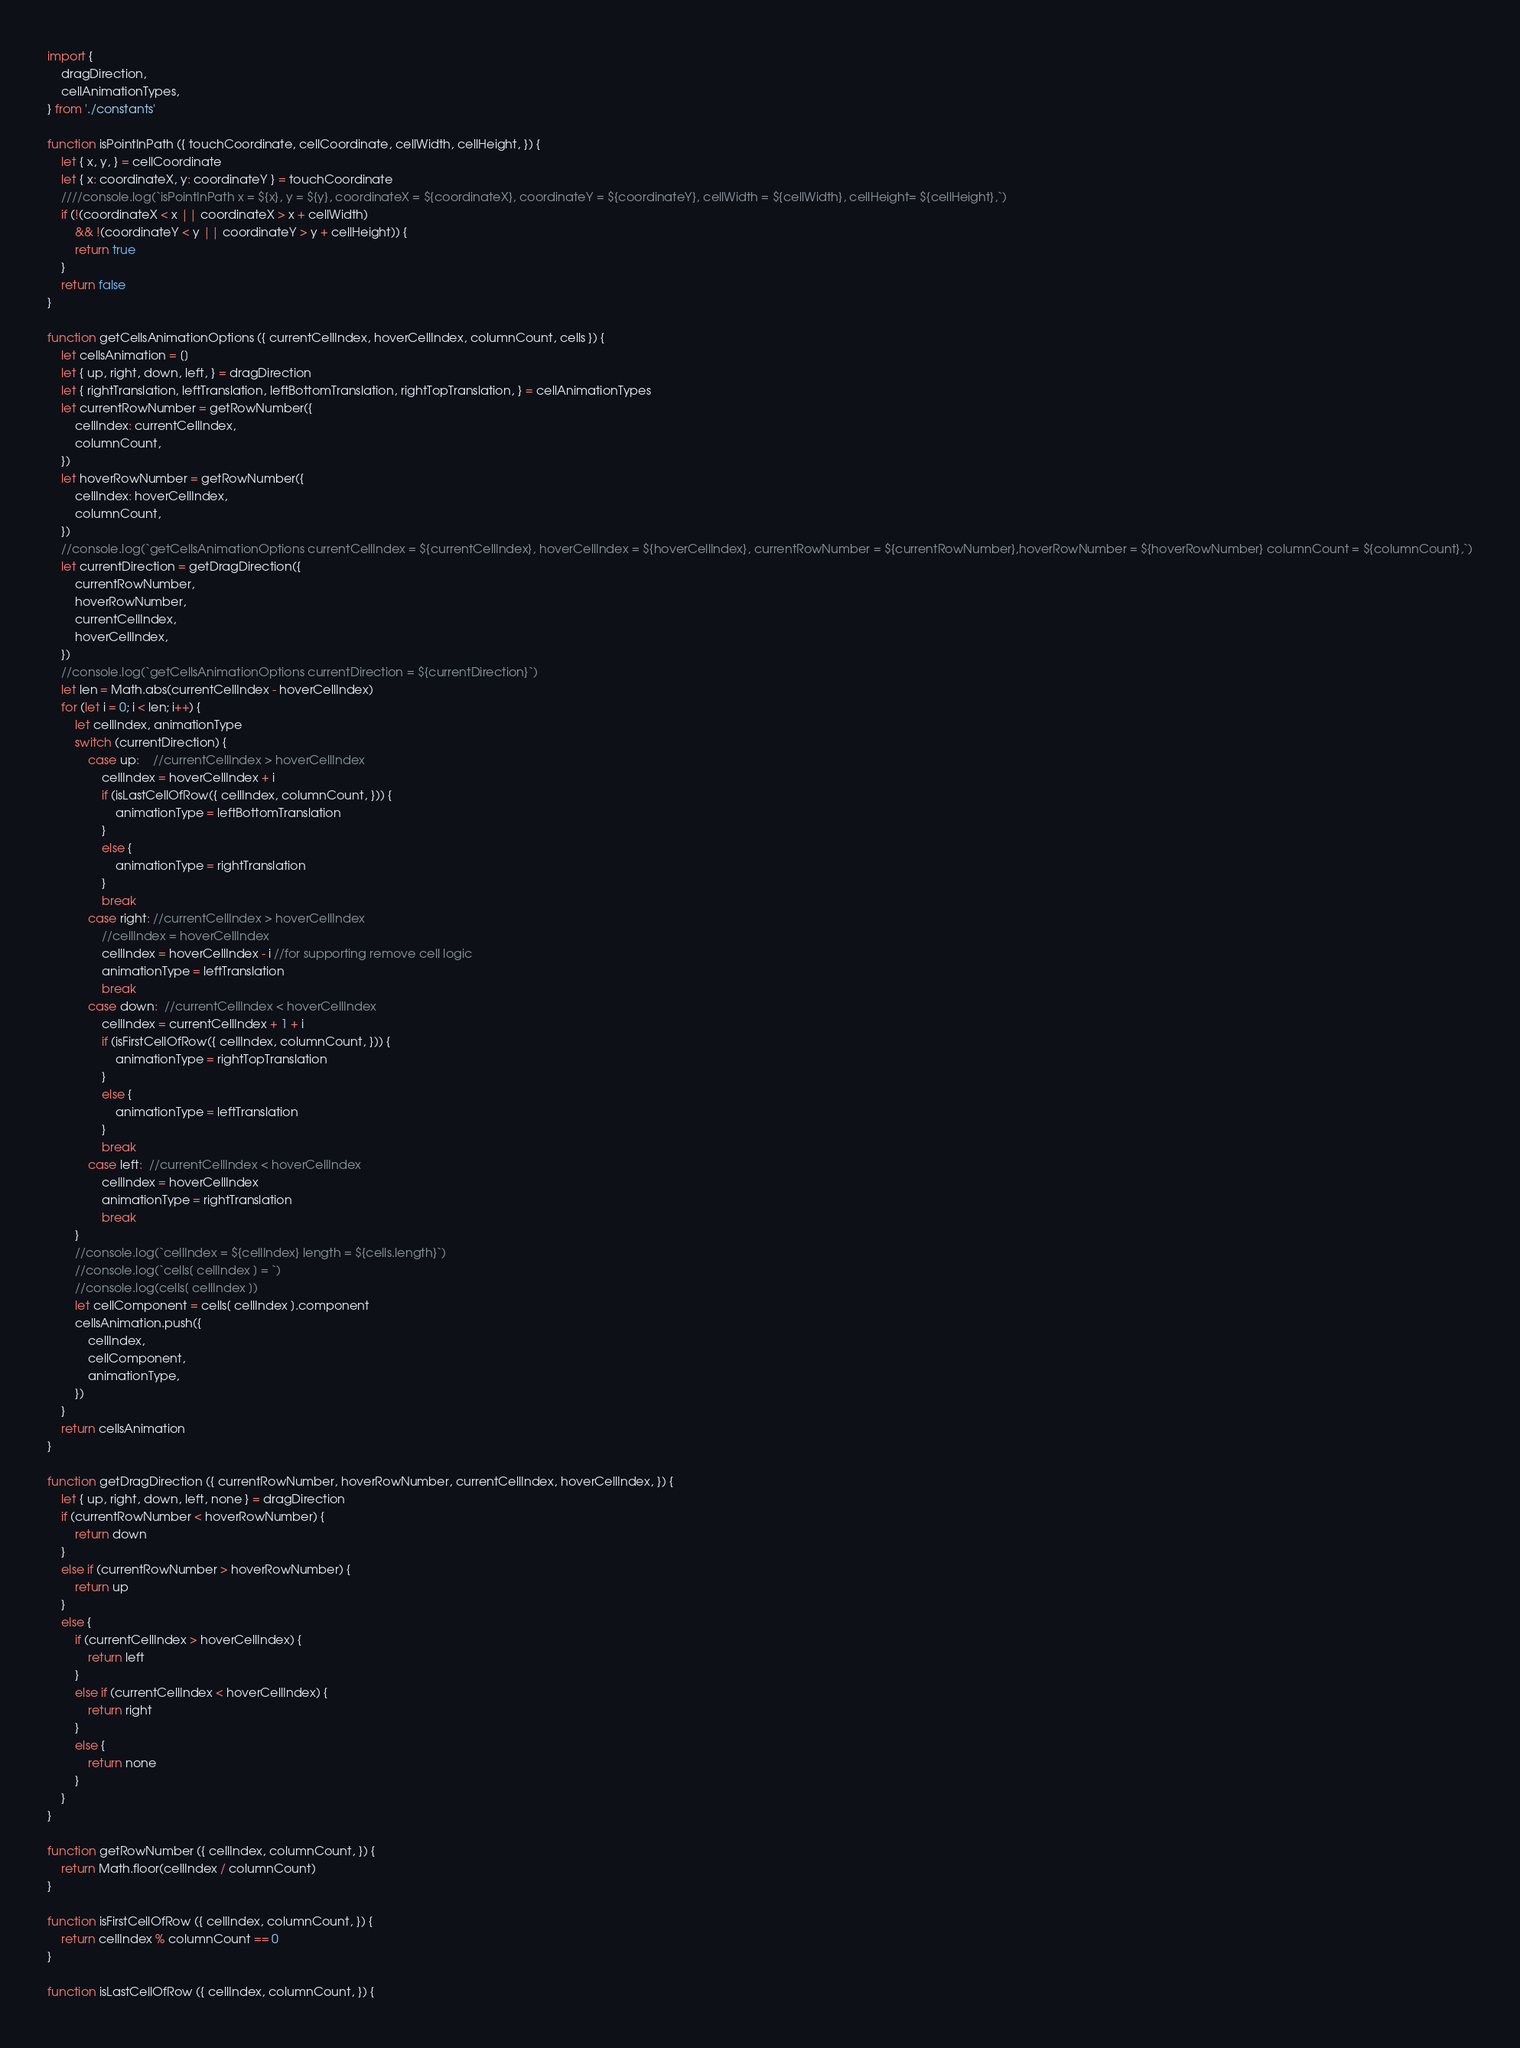Convert code to text. <code><loc_0><loc_0><loc_500><loc_500><_JavaScript_>import {
    dragDirection,
    cellAnimationTypes,
} from './constants'

function isPointInPath ({ touchCoordinate, cellCoordinate, cellWidth, cellHeight, }) {
    let { x, y, } = cellCoordinate
    let { x: coordinateX, y: coordinateY } = touchCoordinate
    ////console.log(`isPointInPath x = ${x}, y = ${y}, coordinateX = ${coordinateX}, coordinateY = ${coordinateY}, cellWidth = ${cellWidth}, cellHeight= ${cellHeight},`)
    if (!(coordinateX < x || coordinateX > x + cellWidth)
        && !(coordinateY < y || coordinateY > y + cellHeight)) {
        return true
    }
    return false
}

function getCellsAnimationOptions ({ currentCellIndex, hoverCellIndex, columnCount, cells }) {
    let cellsAnimation = []
    let { up, right, down, left, } = dragDirection
    let { rightTranslation, leftTranslation, leftBottomTranslation, rightTopTranslation, } = cellAnimationTypes
    let currentRowNumber = getRowNumber({
        cellIndex: currentCellIndex,
        columnCount,
    })
    let hoverRowNumber = getRowNumber({
        cellIndex: hoverCellIndex,
        columnCount,
    })
    //console.log(`getCellsAnimationOptions currentCellIndex = ${currentCellIndex}, hoverCellIndex = ${hoverCellIndex}, currentRowNumber = ${currentRowNumber},hoverRowNumber = ${hoverRowNumber} columnCount = ${columnCount},`)
    let currentDirection = getDragDirection({
        currentRowNumber,
        hoverRowNumber,
        currentCellIndex,
        hoverCellIndex,
    })
    //console.log(`getCellsAnimationOptions currentDirection = ${currentDirection}`)
    let len = Math.abs(currentCellIndex - hoverCellIndex)
    for (let i = 0; i < len; i++) {
        let cellIndex, animationType
        switch (currentDirection) {
            case up:    //currentCellIndex > hoverCellIndex
                cellIndex = hoverCellIndex + i
                if (isLastCellOfRow({ cellIndex, columnCount, })) {
                    animationType = leftBottomTranslation
                }
                else {
                    animationType = rightTranslation
                }
                break
            case right: //currentCellIndex > hoverCellIndex
                //cellIndex = hoverCellIndex
                cellIndex = hoverCellIndex - i //for supporting remove cell logic
                animationType = leftTranslation
                break
            case down:  //currentCellIndex < hoverCellIndex
                cellIndex = currentCellIndex + 1 + i
                if (isFirstCellOfRow({ cellIndex, columnCount, })) {
                    animationType = rightTopTranslation
                }
                else {
                    animationType = leftTranslation
                }
                break
            case left:  //currentCellIndex < hoverCellIndex
                cellIndex = hoverCellIndex
                animationType = rightTranslation
                break
        }
        //console.log(`cellIndex = ${cellIndex} length = ${cells.length}`)
        //console.log(`cells[ cellIndex ] = `)
        //console.log(cells[ cellIndex ])
        let cellComponent = cells[ cellIndex ].component
        cellsAnimation.push({
            cellIndex,
            cellComponent,
            animationType,
        })
    }
    return cellsAnimation
}

function getDragDirection ({ currentRowNumber, hoverRowNumber, currentCellIndex, hoverCellIndex, }) {
    let { up, right, down, left, none } = dragDirection
    if (currentRowNumber < hoverRowNumber) {
        return down
    }
    else if (currentRowNumber > hoverRowNumber) {
        return up
    }
    else {
        if (currentCellIndex > hoverCellIndex) {
            return left
        }
        else if (currentCellIndex < hoverCellIndex) {
            return right
        }
        else {
            return none
        }
    }
}

function getRowNumber ({ cellIndex, columnCount, }) {
    return Math.floor(cellIndex / columnCount)
}

function isFirstCellOfRow ({ cellIndex, columnCount, }) {
    return cellIndex % columnCount == 0
}

function isLastCellOfRow ({ cellIndex, columnCount, }) {</code> 